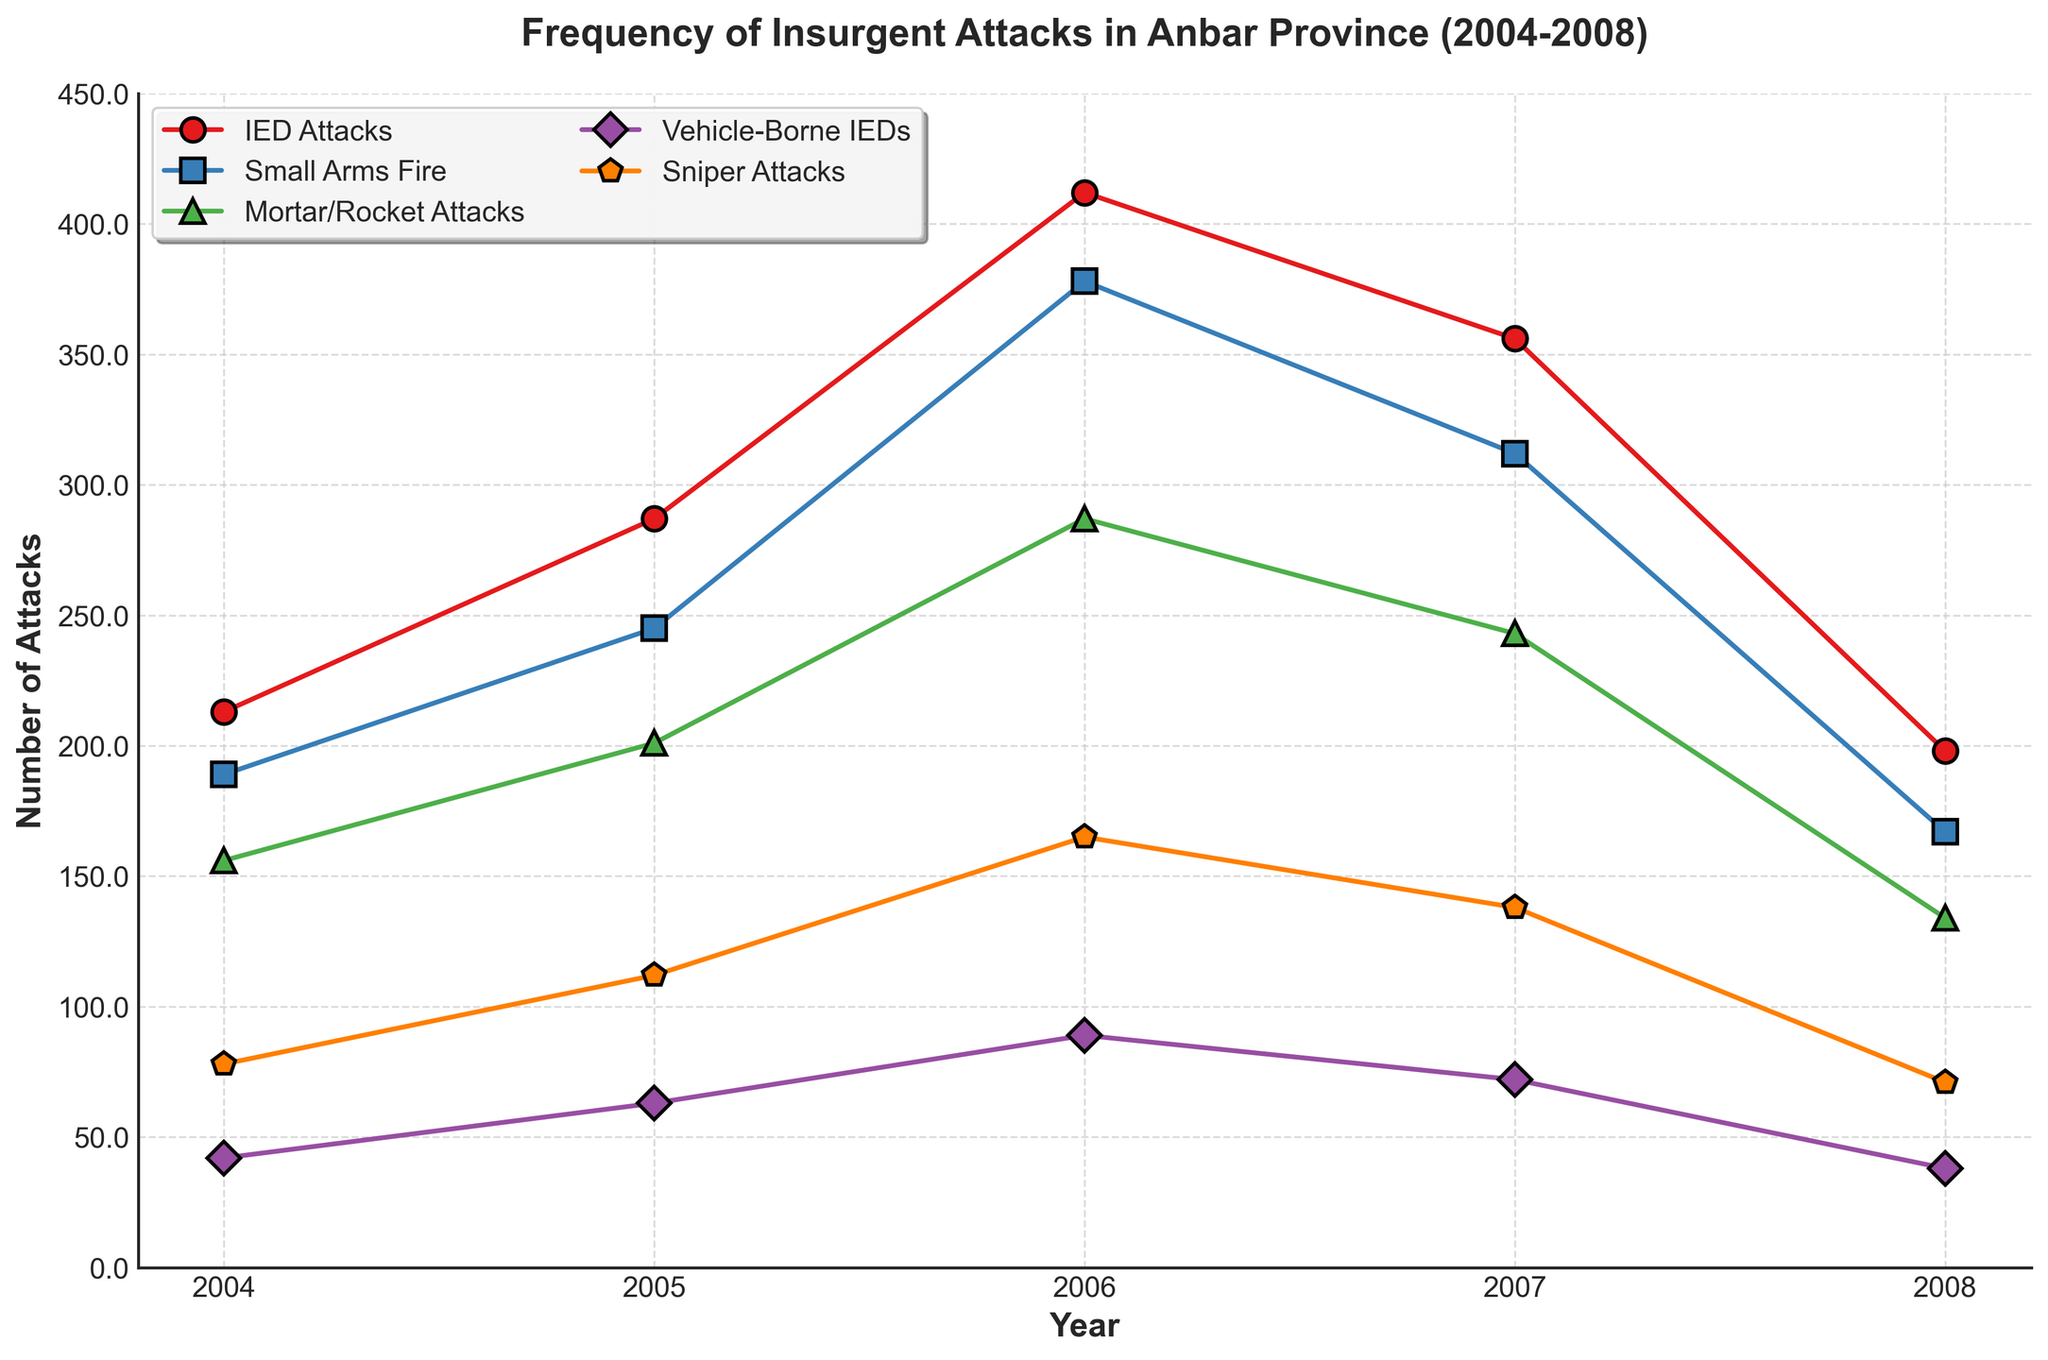What's the trend of IED Attacks from 2004 to 2008? The line representing IED Attacks starts at 213 in 2004, increases to 287 in 2005, peaks at 412 in 2006, then decreases to 356 in 2007 and further drops to 198 in 2008.
Answer: IED Attacks peaked in 2006 and then declined Which year saw the highest number of Small Arms Fire attacks? Observing the Small Arms Fire line, the highest point is in 2006 with 378 attacks.
Answer: 2006 How did the number of Sniper Attacks change from 2004 to 2008? The Sniper Attacks line starts at 78 in 2004, increases to 112 in 2005, peaks at 165 in 2006, then decreases to 138 in 2007 and further to 71 in 2008.
Answer: Increased until 2006, then decreased Which years had fewer than 50 Vehicle-Borne IEDs? The Vehicle-Borne IEDs line is below the 50 mark in 2004 and 2008.
Answer: 2004 and 2008 What was the total number of attacks in 2007 for all types combined? To find the total for 2007, sum the number for each type: 356 (IED Attacks) + 312 (Small Arms Fire) + 243 (Mortar/Rocket Attacks) + 72 (Vehicle-Borne IEDs) + 138 (Sniper Attacks) = 1121.
Answer: 1121 Which type of attack saw the most significant decrease from 2006 to 2008? Observing the differences from 2006 to 2008: IED Attacks (412 to 198 = -214), Small Arms Fire (378 to 167 = -211), Mortar/Rocket Attacks (287 to 134 = -153), Vehicle-Borne IEDs (89 to 38 = -51), Sniper Attacks (165 to 71 = -94). The largest decrease is in IED Attacks with a drop of 214.
Answer: IED Attacks Between 2004 and 2008, which attack type had the most volatile changes (largest increases and decreases)? Compare the ranges of each line: IED Attacks (max 412, min 198, range 214), Small Arms Fire (max 378, min 167, range 211), Mortar/Rocket Attacks (max 287, min 134, range 153), Vehicle-Borne IEDs (max 89, min 38, range 51), Sniper Attacks (max 165, min 71, range 94). IED Attacks had the largest range of 214.
Answer: IED Attacks In which year did Mortar/Rocket Attacks peak, and what was the value? The highest point for Mortar/Rocket Attacks is in 2006 with a value of 287.
Answer: 2006, 287 